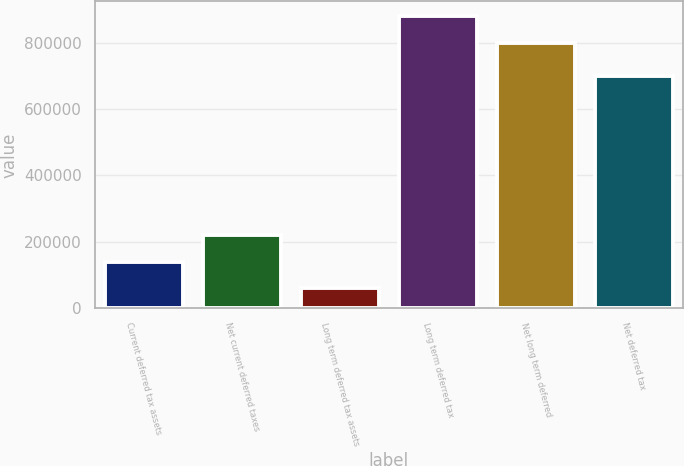Convert chart to OTSL. <chart><loc_0><loc_0><loc_500><loc_500><bar_chart><fcel>Current deferred tax assets<fcel>Net current deferred taxes<fcel>Long term deferred tax assets<fcel>Long term deferred tax<fcel>Net long term deferred<fcel>Net deferred tax<nl><fcel>140415<fcel>220409<fcel>60421<fcel>879933<fcel>799939<fcel>698488<nl></chart> 